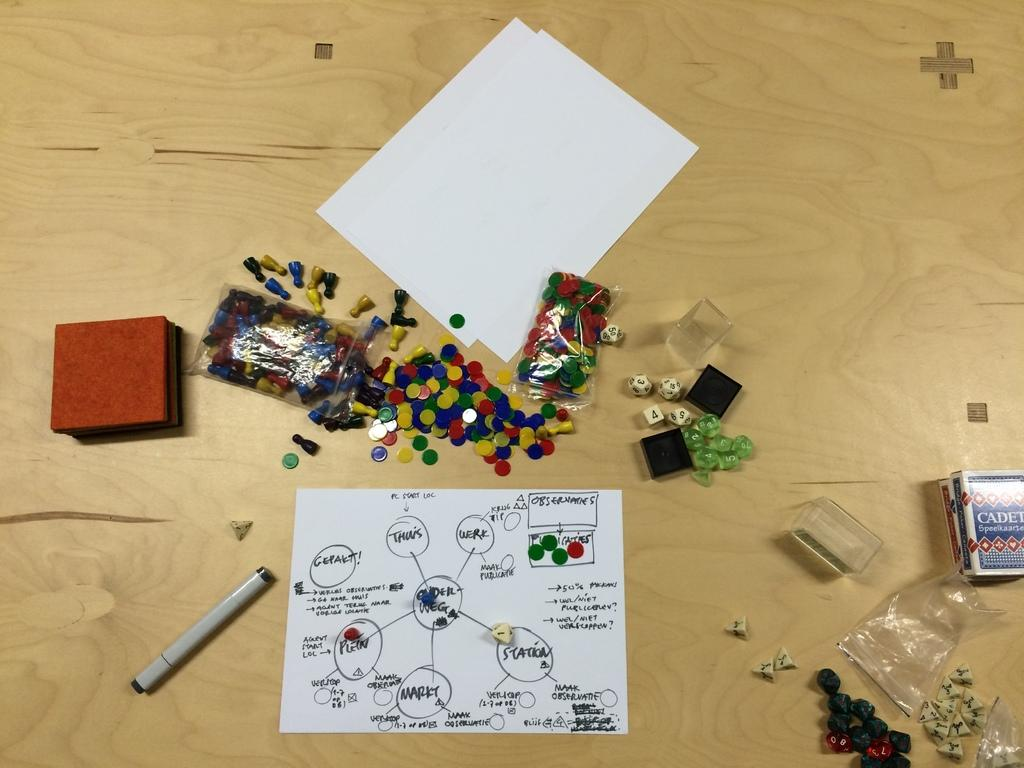What objects are present on the wooden floor or desk in the image? Papers, dice, and boxes are present on the wooden floor or desk in the image. What game-related object can be seen in the image? Dice are present in the image. What type of structure is visible in the image? There is a pent in the image. What is the surface on which the objects are placed in the image? The wooden floor or desk is visible at the bottom of the image. What type of sea creature can be seen swimming in the image? There is no sea creature present in the image; it does not depict any aquatic environment. What emotion is being expressed by the objects in the image? Objects do not express emotions; they are inanimate. 